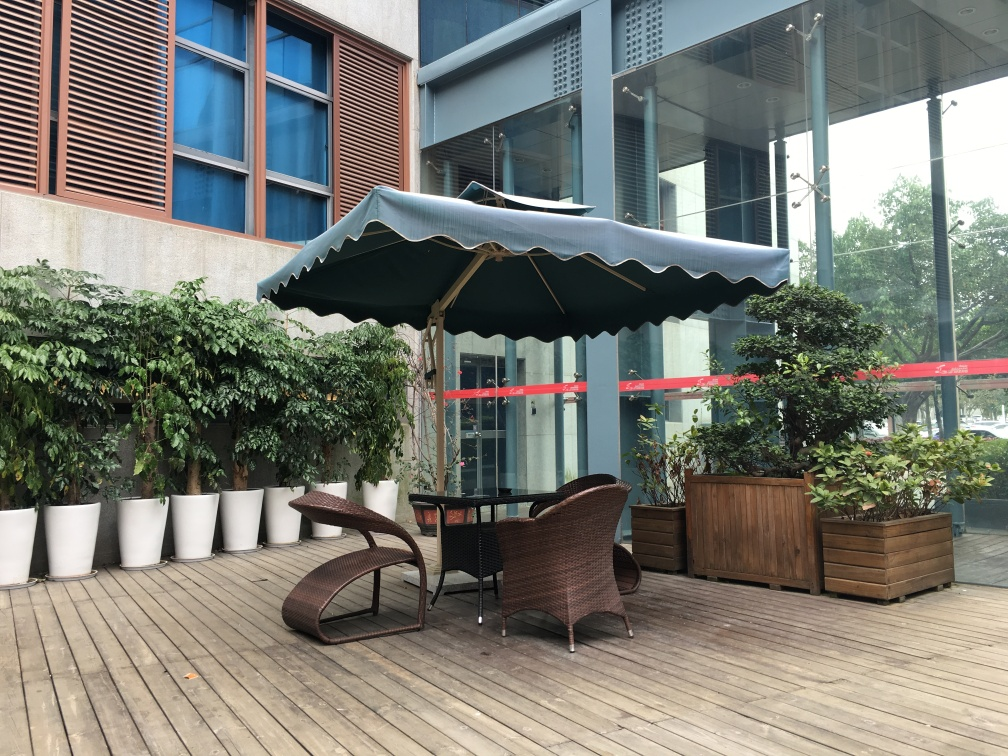What are the texture details like for the ground? The ground is covered with wooden planks arranged in a horizontal pattern. The wood has a natural, weathered look with variations in color from a light beige to a darker brown, suggesting regular exposure to the elements. The texture appears slightly rough, with lines demarcating each plank and creating a visually striated effect. 